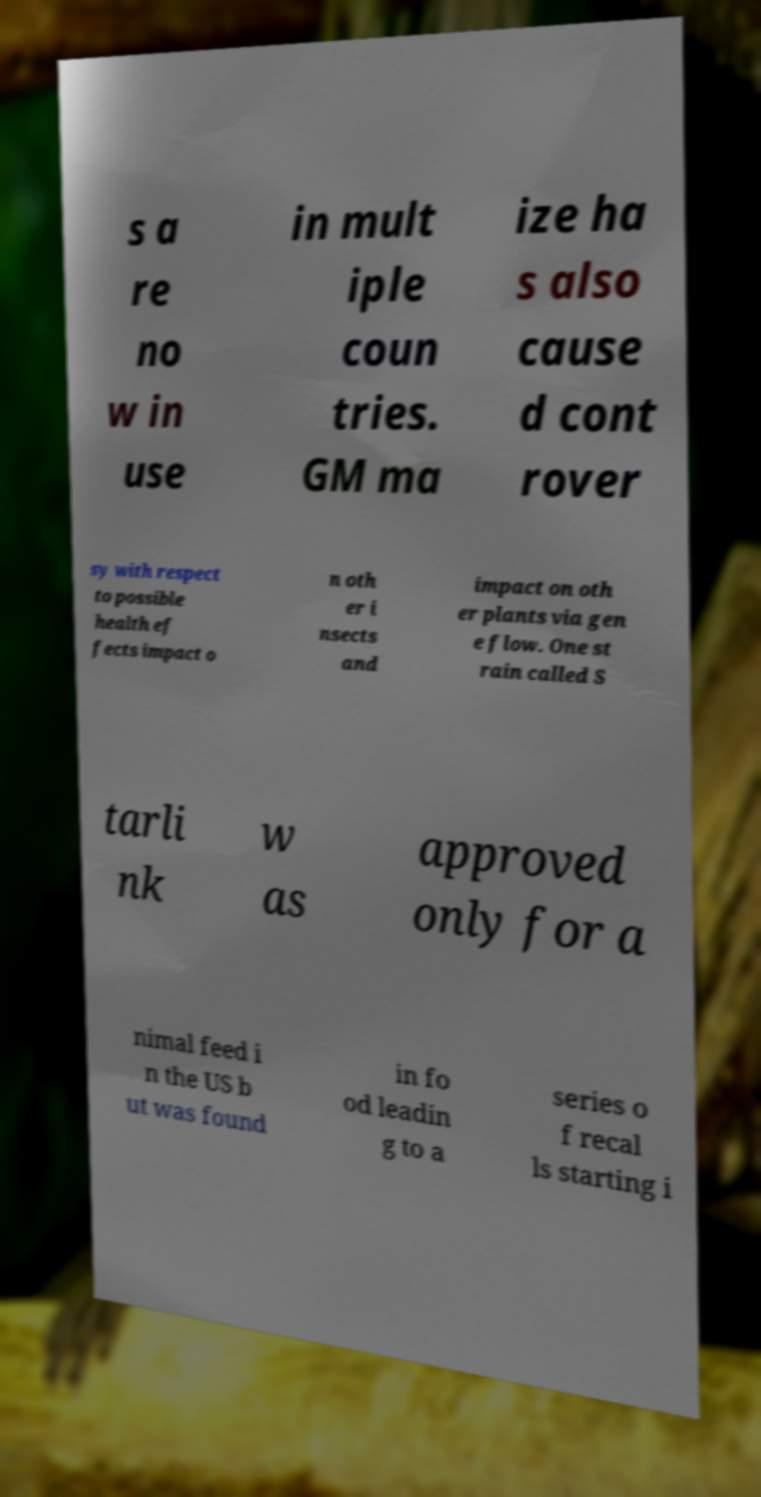I need the written content from this picture converted into text. Can you do that? s a re no w in use in mult iple coun tries. GM ma ize ha s also cause d cont rover sy with respect to possible health ef fects impact o n oth er i nsects and impact on oth er plants via gen e flow. One st rain called S tarli nk w as approved only for a nimal feed i n the US b ut was found in fo od leadin g to a series o f recal ls starting i 